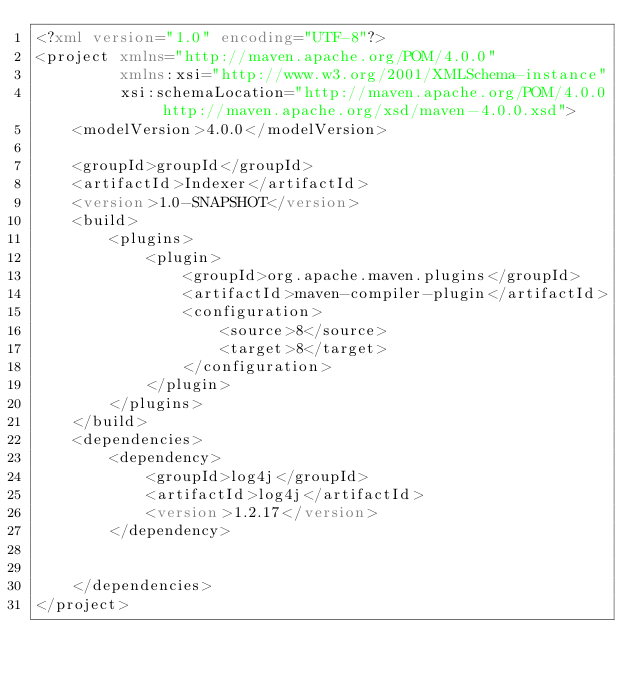Convert code to text. <code><loc_0><loc_0><loc_500><loc_500><_XML_><?xml version="1.0" encoding="UTF-8"?>
<project xmlns="http://maven.apache.org/POM/4.0.0"
         xmlns:xsi="http://www.w3.org/2001/XMLSchema-instance"
         xsi:schemaLocation="http://maven.apache.org/POM/4.0.0 http://maven.apache.org/xsd/maven-4.0.0.xsd">
    <modelVersion>4.0.0</modelVersion>

    <groupId>groupId</groupId>
    <artifactId>Indexer</artifactId>
    <version>1.0-SNAPSHOT</version>
    <build>
        <plugins>
            <plugin>
                <groupId>org.apache.maven.plugins</groupId>
                <artifactId>maven-compiler-plugin</artifactId>
                <configuration>
                    <source>8</source>
                    <target>8</target>
                </configuration>
            </plugin>
        </plugins>
    </build>
    <dependencies>
        <dependency>
            <groupId>log4j</groupId>
            <artifactId>log4j</artifactId>
            <version>1.2.17</version>
        </dependency>


    </dependencies>
</project>
</code> 